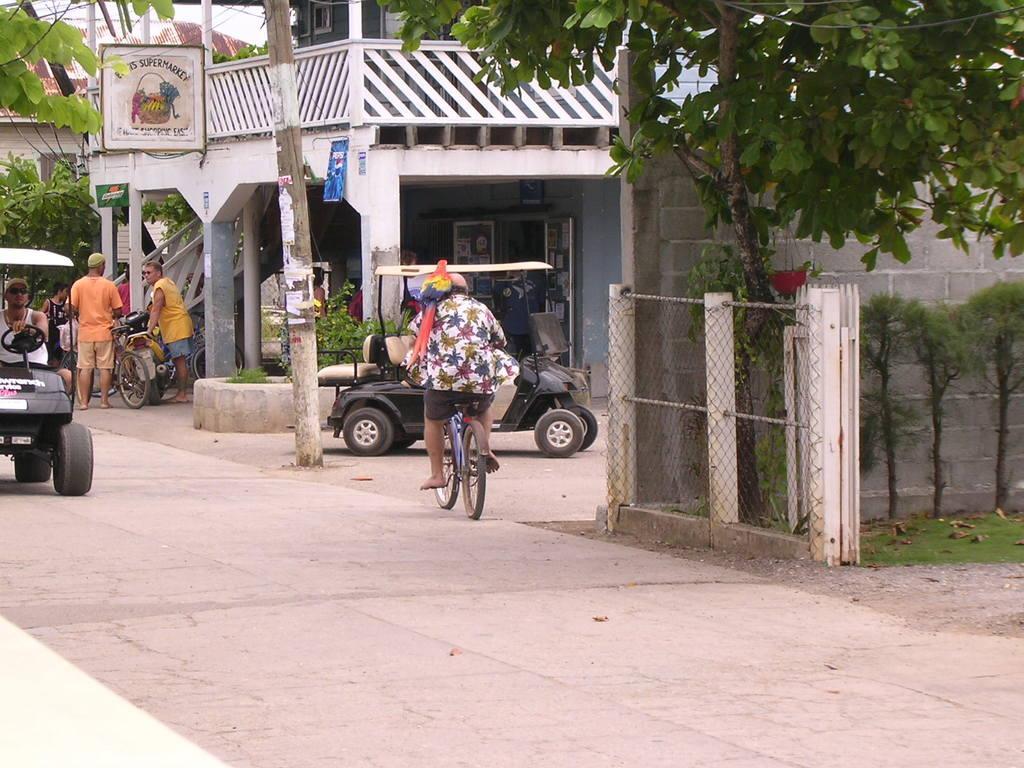In one or two sentences, can you explain what this image depicts? This image is clicked on a street, there are two golf vehicles going on the road on either sides and a person riding bicycle in the middle, in the front there is a building with plants beside it and on the right side there is a plant inside a fence on grassland. 